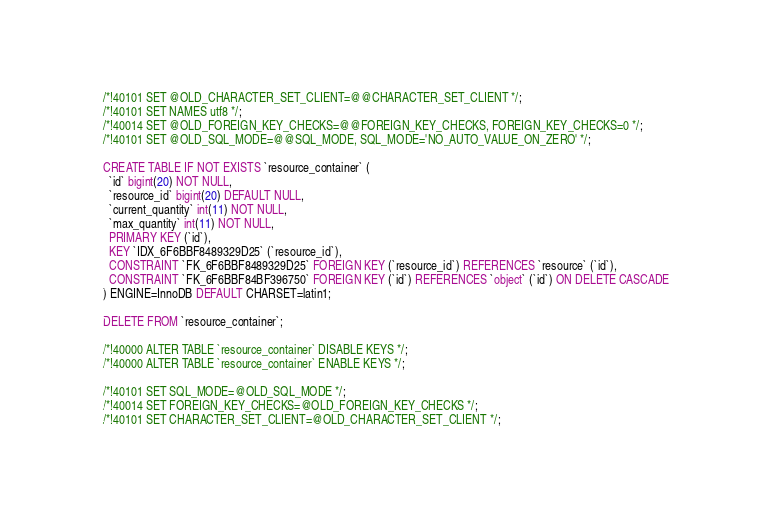<code> <loc_0><loc_0><loc_500><loc_500><_SQL_>
/*!40101 SET @OLD_CHARACTER_SET_CLIENT=@@CHARACTER_SET_CLIENT */;
/*!40101 SET NAMES utf8 */;
/*!40014 SET @OLD_FOREIGN_KEY_CHECKS=@@FOREIGN_KEY_CHECKS, FOREIGN_KEY_CHECKS=0 */;
/*!40101 SET @OLD_SQL_MODE=@@SQL_MODE, SQL_MODE='NO_AUTO_VALUE_ON_ZERO' */;

CREATE TABLE IF NOT EXISTS `resource_container` (
  `id` bigint(20) NOT NULL,
  `resource_id` bigint(20) DEFAULT NULL,
  `current_quantity` int(11) NOT NULL,
  `max_quantity` int(11) NOT NULL,
  PRIMARY KEY (`id`),
  KEY `IDX_6F6BBF8489329D25` (`resource_id`),
  CONSTRAINT `FK_6F6BBF8489329D25` FOREIGN KEY (`resource_id`) REFERENCES `resource` (`id`),
  CONSTRAINT `FK_6F6BBF84BF396750` FOREIGN KEY (`id`) REFERENCES `object` (`id`) ON DELETE CASCADE
) ENGINE=InnoDB DEFAULT CHARSET=latin1;

DELETE FROM `resource_container`;
    
/*!40000 ALTER TABLE `resource_container` DISABLE KEYS */;
/*!40000 ALTER TABLE `resource_container` ENABLE KEYS */;

/*!40101 SET SQL_MODE=@OLD_SQL_MODE */;
/*!40014 SET FOREIGN_KEY_CHECKS=@OLD_FOREIGN_KEY_CHECKS */;
/*!40101 SET CHARACTER_SET_CLIENT=@OLD_CHARACTER_SET_CLIENT */;
</code> 